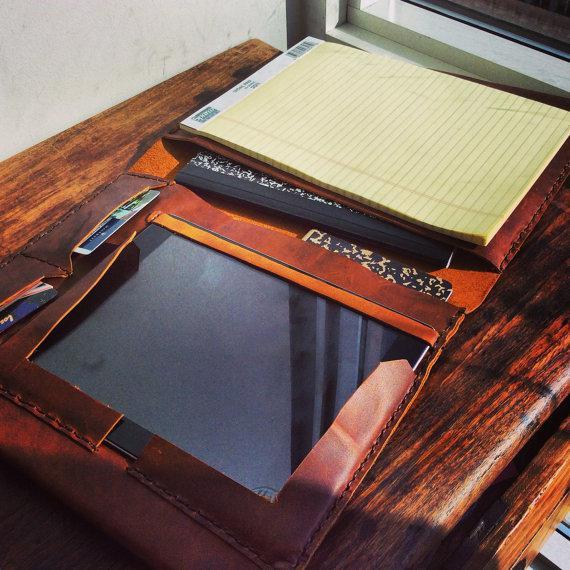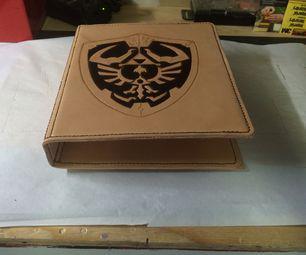The first image is the image on the left, the second image is the image on the right. Considering the images on both sides, is "Both binders are against a white background." valid? Answer yes or no. No. The first image is the image on the left, the second image is the image on the right. Given the left and right images, does the statement "Each image contains a single brown binder" hold true? Answer yes or no. Yes. 